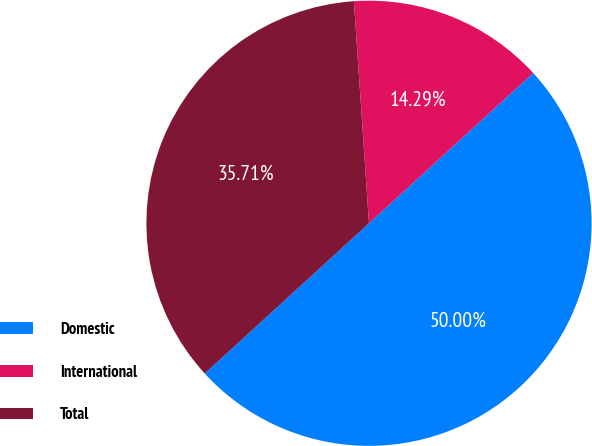Convert chart. <chart><loc_0><loc_0><loc_500><loc_500><pie_chart><fcel>Domestic<fcel>International<fcel>Total<nl><fcel>50.0%<fcel>14.29%<fcel>35.71%<nl></chart> 